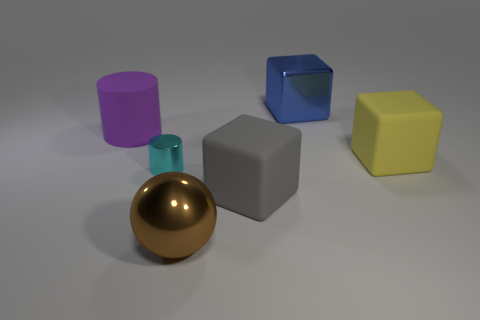Can you describe the scene in the image? The image depicts a neatly arranged collection of geometric shapes on a flat surface. There are two cubes, one blue and the other yellow; a gray block with a smooth surface; a pink cylinder; and a gold, reflective sphere. The setting exudes a 3D-rendered quality with a simple, uncluttered backdrop that enhances the visibility of each object's color and material. 